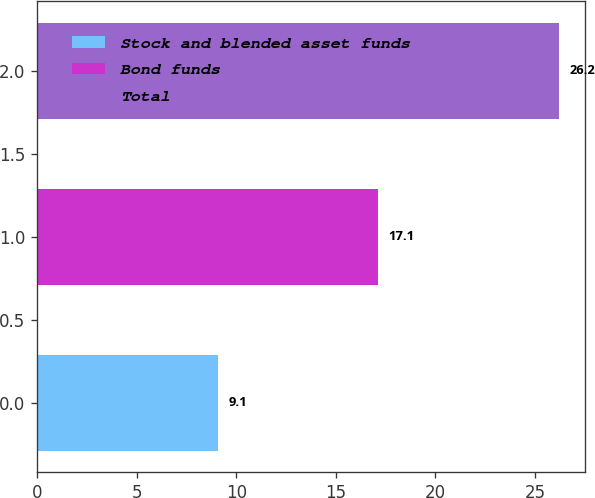Convert chart. <chart><loc_0><loc_0><loc_500><loc_500><bar_chart><fcel>Stock and blended asset funds<fcel>Bond funds<fcel>Total<nl><fcel>9.1<fcel>17.1<fcel>26.2<nl></chart> 